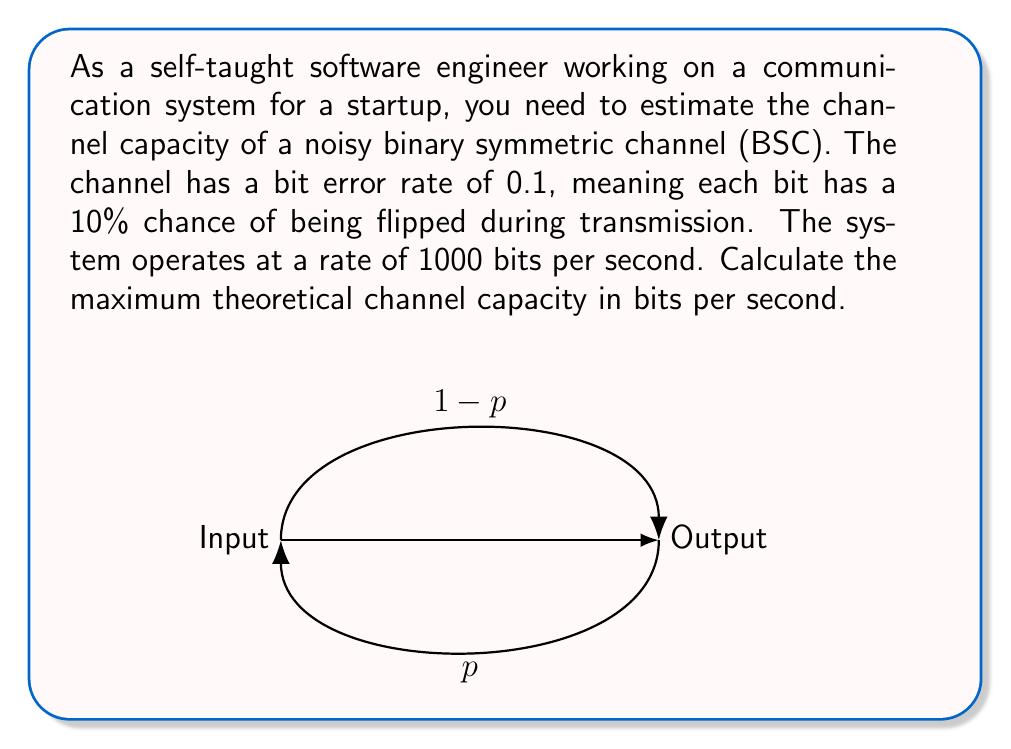Could you help me with this problem? To solve this problem, we'll use the channel capacity formula for a binary symmetric channel (BSC) and apply it to the given scenario. Let's break it down step-by-step:

1) The channel capacity formula for a BSC is:

   $$C = 1 - H(p)$$

   where $C$ is the capacity in bits per channel use, and $H(p)$ is the binary entropy function.

2) The binary entropy function is defined as:

   $$H(p) = -p \log_2(p) - (1-p) \log_2(1-p)$$

3) In our case, $p = 0.1$ (the bit error rate). Let's calculate $H(p)$:

   $$H(0.1) = -0.1 \log_2(0.1) - 0.9 \log_2(0.9)$$
   $$= -0.1 \cdot (-3.32193) - 0.9 \cdot (-0.15200)$$
   $$= 0.33219 + 0.13680 = 0.46899$$

4) Now we can calculate the capacity per channel use:

   $$C = 1 - H(0.1) = 1 - 0.46899 = 0.53101$$

5) This means we can transmit 0.53101 bits of information per channel use.

6) Given that our system operates at 1000 bits per second, we need to multiply our capacity by 1000 to get the channel capacity in bits per second:

   $$\text{Channel Capacity} = 0.53101 \cdot 1000 = 531.01 \text{ bits/second}$$

Therefore, the maximum theoretical channel capacity is approximately 531.01 bits per second.
Answer: 531.01 bits/second 